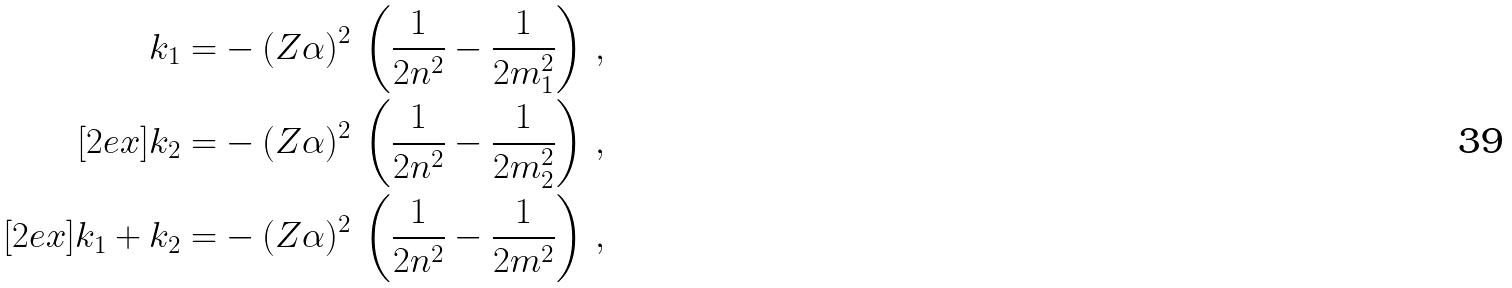<formula> <loc_0><loc_0><loc_500><loc_500>k _ { 1 } = & - ( Z \alpha ) ^ { 2 } \, \left ( \frac { 1 } { 2 n ^ { 2 } } - \frac { 1 } { 2 m _ { 1 } ^ { 2 } } \right ) \, , \\ [ 2 e x ] k _ { 2 } = & - ( Z \alpha ) ^ { 2 } \, \left ( \frac { 1 } { 2 n ^ { 2 } } - \frac { 1 } { 2 m _ { 2 } ^ { 2 } } \right ) \, , \\ [ 2 e x ] k _ { 1 } + k _ { 2 } = & - ( Z \alpha ) ^ { 2 } \, \left ( \frac { 1 } { 2 n ^ { 2 } } - \frac { 1 } { 2 m ^ { 2 } } \right ) \, ,</formula> 